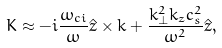<formula> <loc_0><loc_0><loc_500><loc_500>K \approx - i \frac { \omega _ { c i } } { \omega } \hat { z } \times k + \frac { k _ { \perp } ^ { 2 } k _ { z } c _ { s } ^ { 2 } } { \omega ^ { 2 } } \hat { z } ,</formula> 